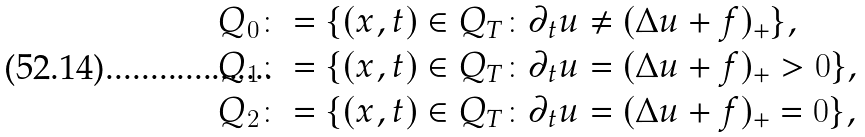<formula> <loc_0><loc_0><loc_500><loc_500>Q _ { 0 } & \colon = \{ ( x , t ) \in Q _ { T } \colon \partial _ { t } u \neq ( \Delta u + f ) _ { + } \} , \\ Q _ { 1 } & \colon = \{ ( x , t ) \in Q _ { T } \colon \partial _ { t } u = ( \Delta u + f ) _ { + } > 0 \} , \\ Q _ { 2 } & \colon = \{ ( x , t ) \in Q _ { T } \colon \partial _ { t } u = ( \Delta u + f ) _ { + } = 0 \} ,</formula> 